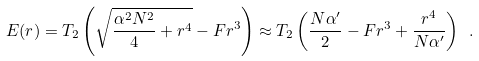Convert formula to latex. <formula><loc_0><loc_0><loc_500><loc_500>E ( r ) = T _ { 2 } \left ( \sqrt { { \frac { \alpha ^ { 2 } N ^ { 2 } } { 4 } } + r ^ { 4 } } - F r ^ { 3 } \right ) \approx T _ { 2 } \left ( { \frac { N \alpha ^ { \prime } } { 2 } } - F r ^ { 3 } + { \frac { r ^ { 4 } } { N \alpha ^ { \prime } } } \right ) \ .</formula> 